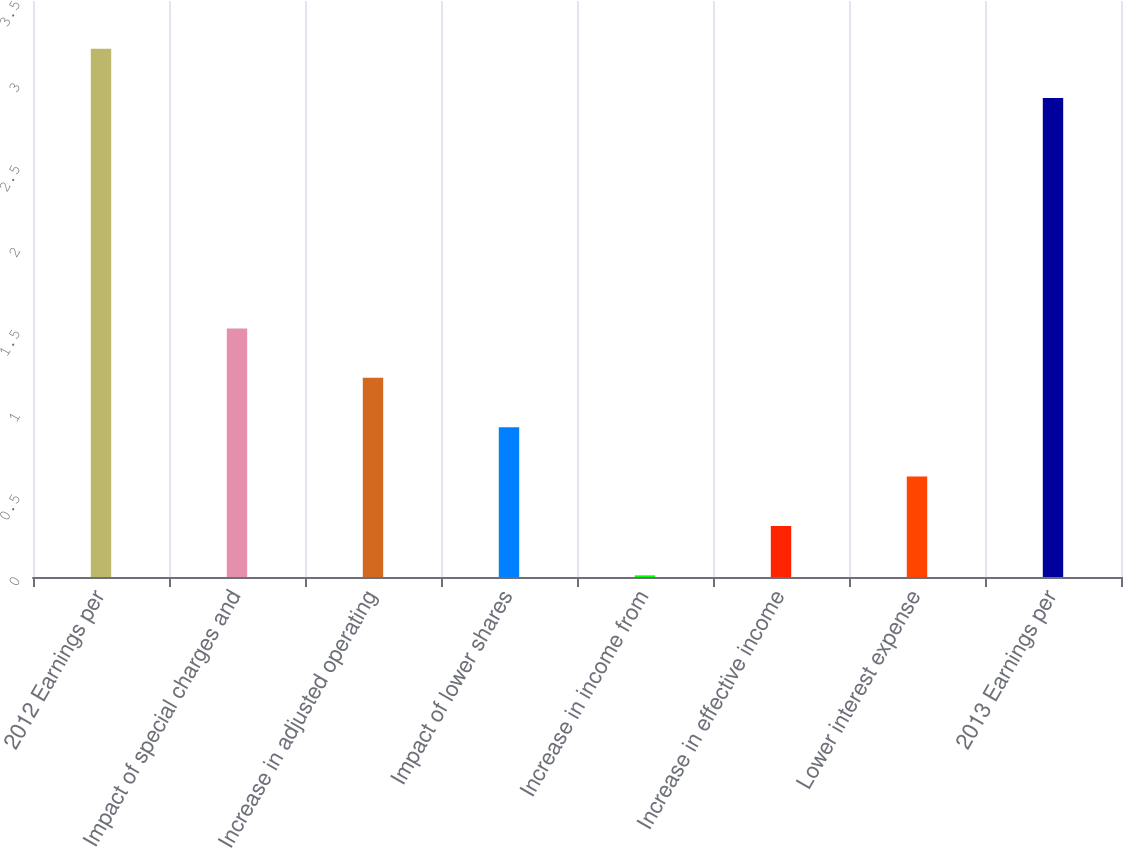<chart> <loc_0><loc_0><loc_500><loc_500><bar_chart><fcel>2012 Earnings per<fcel>Impact of special charges and<fcel>Increase in adjusted operating<fcel>Impact of lower shares<fcel>Increase in income from<fcel>Increase in effective income<fcel>Lower interest expense<fcel>2013 Earnings per<nl><fcel>3.21<fcel>1.51<fcel>1.21<fcel>0.91<fcel>0.01<fcel>0.31<fcel>0.61<fcel>2.91<nl></chart> 